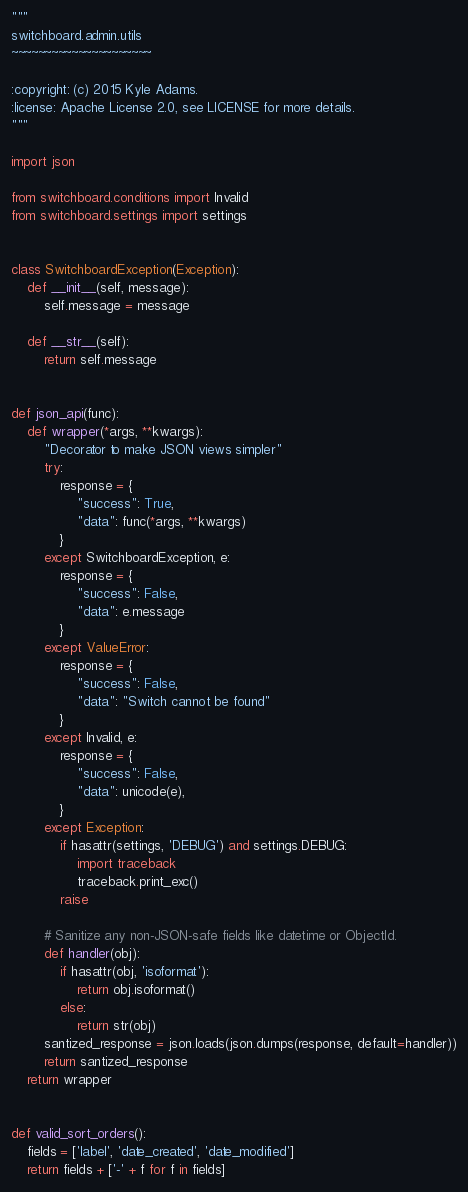<code> <loc_0><loc_0><loc_500><loc_500><_Python_>"""
switchboard.admin.utils
~~~~~~~~~~~~~~~~~~~~~

:copyright: (c) 2015 Kyle Adams.
:license: Apache License 2.0, see LICENSE for more details.
"""

import json

from switchboard.conditions import Invalid
from switchboard.settings import settings


class SwitchboardException(Exception):
    def __init__(self, message):
        self.message = message

    def __str__(self):
        return self.message


def json_api(func):
    def wrapper(*args, **kwargs):
        "Decorator to make JSON views simpler"
        try:
            response = {
                "success": True,
                "data": func(*args, **kwargs)
            }
        except SwitchboardException, e:
            response = {
                "success": False,
                "data": e.message
            }
        except ValueError:
            response = {
                "success": False,
                "data": "Switch cannot be found"
            }
        except Invalid, e:
            response = {
                "success": False,
                "data": unicode(e),
            }
        except Exception:
            if hasattr(settings, 'DEBUG') and settings.DEBUG:
                import traceback
                traceback.print_exc()
            raise

        # Sanitize any non-JSON-safe fields like datetime or ObjectId.
        def handler(obj):
            if hasattr(obj, 'isoformat'):
                return obj.isoformat()
            else:
                return str(obj)
        santized_response = json.loads(json.dumps(response, default=handler))
        return santized_response
    return wrapper


def valid_sort_orders():
    fields = ['label', 'date_created', 'date_modified']
    return fields + ['-' + f for f in fields]
</code> 